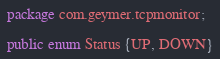Convert code to text. <code><loc_0><loc_0><loc_500><loc_500><_Java_>package com.geymer.tcpmonitor;

public enum Status {UP, DOWN}
</code> 